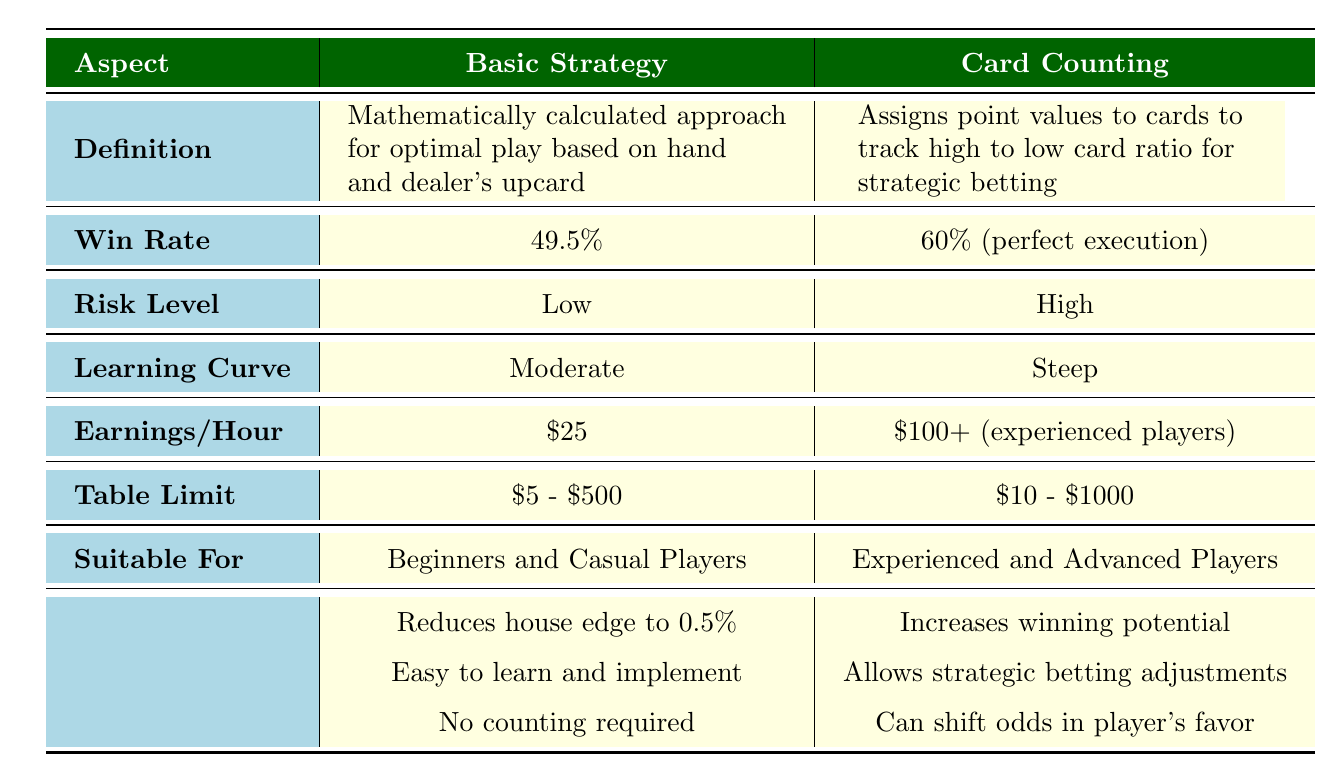What is the win rate for Basic Strategy? The win rate for Basic Strategy is clearly stated in the table. Looking under the "Win Rate" row for Basic Strategy, it is listed as 49.5%.
Answer: 49.5% What is the risk level associated with Card Counting? By examining the "Risk Level" row in the Card Counting column, it indicates that the risk level is classified as High.
Answer: High Which strategy has a higher earnings per hour? To find which strategy has a higher earnings per hour, we compare the values in the "Earnings/Hour" row. Basic Strategy earns $25, while Card Counting earns $100+ for experienced players. Therefore, Card Counting has the higher earnings.
Answer: Card Counting Is the Basic Strategy suitable for advanced players? Looking at the "Suitable For" row for Basic Strategy, it mentions "Beginners and Casual Players," which means it is not suitable for advanced players. Hence, the answer is no.
Answer: No What are the key benefits of using Basic Strategy compared to Card Counting? The key benefits include three points listed under Basic Strategy: it reduces the house edge to 0.5%, is easy to learn and implement, and requires no counting. These benefits indicate that Basic Strategy provides a simpler approach.
Answer: Reduces house edge, easy to learn, no counting required What is the difference in win rates between Basic Strategy and Card Counting? The win rate for Card Counting is 60% with perfect execution. To find the difference, we subtract Basic Strategy's win rate (49.5%) from Card Counting's win rate (60%): 60% - 49.5% = 10.5%. Therefore, the difference in win rates is 10.5%.
Answer: 10.5% What is the maximum table limit for Basic Strategy? By reviewing the "Table Limit" row for Basic Strategy, it states the limit is $5 - $500. There are no complicated calculations needed here.
Answer: $5 - $500 Would a beginner player benefit more from Basic Strategy or Card Counting? The table indicates that Basic Strategy is suitable for "Beginners and Casual Players," while Card Counting is designated for "Experienced and Advanced Players." Therefore, a beginner would benefit more from Basic Strategy.
Answer: Basic Strategy How could learning curves affect a player's choice between strategies? The table shows a Moderate learning curve for Basic Strategy and a Steep learning curve for Card Counting. The difficulty relates to how quickly a player could become proficient; since beginners often prefer easier methods, this would influence them to choose Basic Strategy.
Answer: Affects choice toward Basic Strategy 